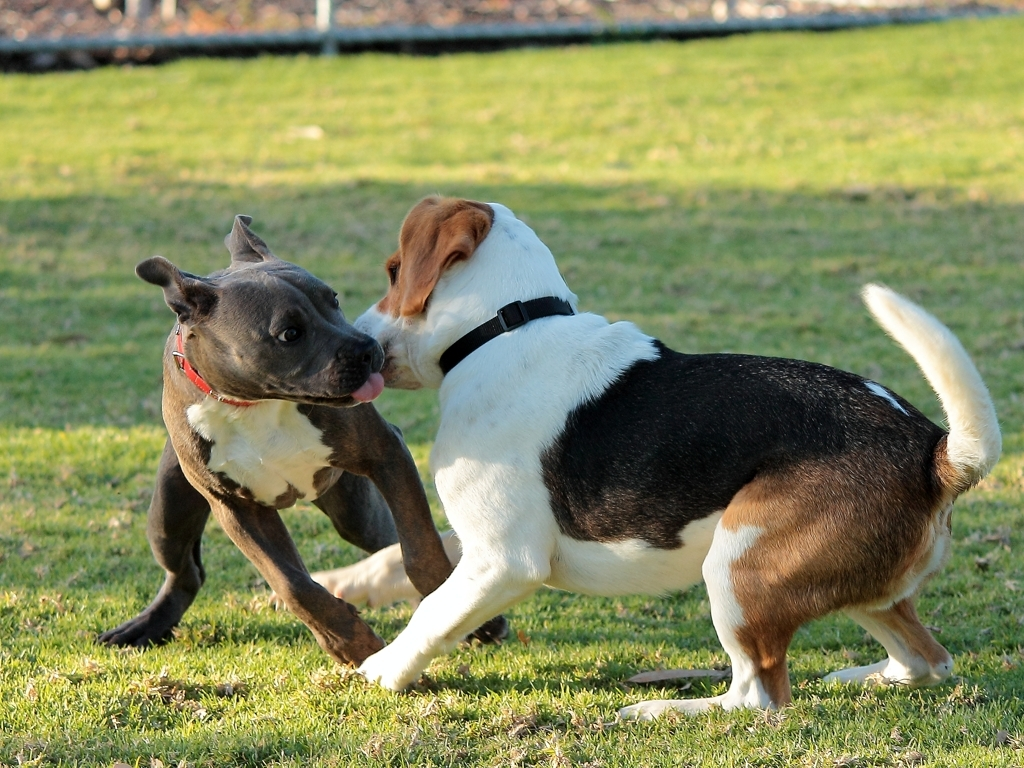What does this picture capture?
A. Still and calm atmosphere
B. The elegance of dogs
C. The surrounding environment
D. The playful antics of two dogs
Answer with the option's letter from the given choices directly.
 D. 